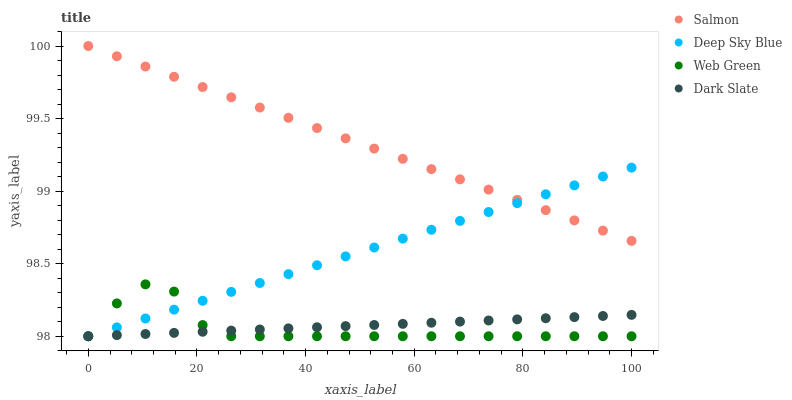Does Web Green have the minimum area under the curve?
Answer yes or no. Yes. Does Salmon have the maximum area under the curve?
Answer yes or no. Yes. Does Salmon have the minimum area under the curve?
Answer yes or no. No. Does Web Green have the maximum area under the curve?
Answer yes or no. No. Is Salmon the smoothest?
Answer yes or no. Yes. Is Web Green the roughest?
Answer yes or no. Yes. Is Web Green the smoothest?
Answer yes or no. No. Is Salmon the roughest?
Answer yes or no. No. Does Dark Slate have the lowest value?
Answer yes or no. Yes. Does Salmon have the lowest value?
Answer yes or no. No. Does Salmon have the highest value?
Answer yes or no. Yes. Does Web Green have the highest value?
Answer yes or no. No. Is Web Green less than Salmon?
Answer yes or no. Yes. Is Salmon greater than Dark Slate?
Answer yes or no. Yes. Does Deep Sky Blue intersect Dark Slate?
Answer yes or no. Yes. Is Deep Sky Blue less than Dark Slate?
Answer yes or no. No. Is Deep Sky Blue greater than Dark Slate?
Answer yes or no. No. Does Web Green intersect Salmon?
Answer yes or no. No. 